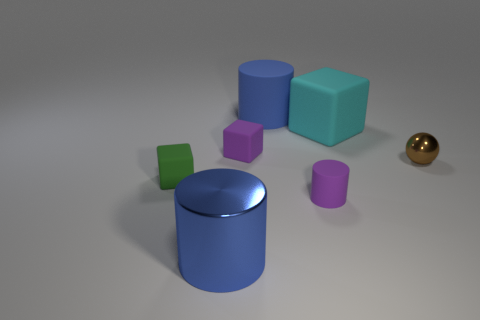How big is the blue matte cylinder?
Your answer should be very brief. Large. There is another big cylinder that is the same color as the large matte cylinder; what is its material?
Offer a very short reply. Metal. Is the color of the tiny rubber thing behind the green rubber thing the same as the tiny cylinder?
Your response must be concise. Yes. What color is the tiny cylinder that is made of the same material as the green cube?
Your answer should be compact. Purple. Is the cyan matte cube the same size as the metal cylinder?
Provide a succinct answer. Yes. What material is the green thing?
Keep it short and to the point. Rubber. What material is the brown thing that is the same size as the green matte cube?
Offer a terse response. Metal. Is there a rubber thing that has the same size as the green matte block?
Provide a short and direct response. Yes. Are there the same number of blue objects right of the cyan rubber object and purple rubber things that are to the left of the metal ball?
Ensure brevity in your answer.  No. Is the number of cyan rubber objects greater than the number of tiny blue matte spheres?
Keep it short and to the point. Yes. 